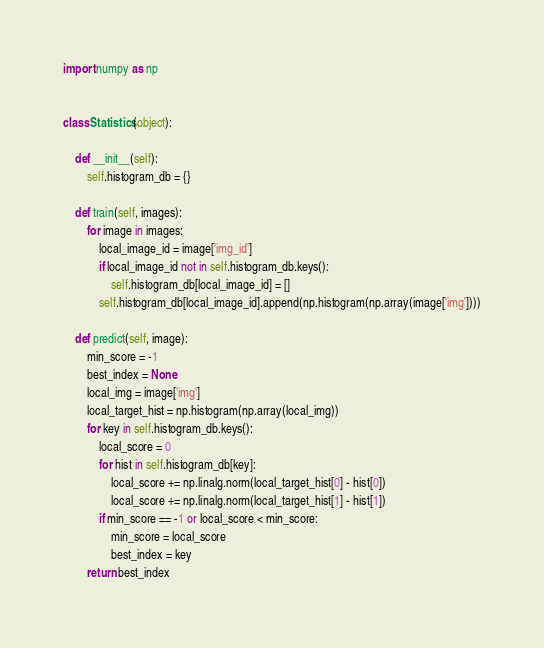<code> <loc_0><loc_0><loc_500><loc_500><_Python_>import numpy as np


class Statistics(object):

    def __init__(self):
        self.histogram_db = {}

    def train(self, images):
        for image in images:
            local_image_id = image['img_id']
            if local_image_id not in self.histogram_db.keys():
                self.histogram_db[local_image_id] = []
            self.histogram_db[local_image_id].append(np.histogram(np.array(image['img'])))

    def predict(self, image):
        min_score = -1
        best_index = None
        local_img = image['img']
        local_target_hist = np.histogram(np.array(local_img))
        for key in self.histogram_db.keys():
            local_score = 0
            for hist in self.histogram_db[key]:
                local_score += np.linalg.norm(local_target_hist[0] - hist[0])
                local_score += np.linalg.norm(local_target_hist[1] - hist[1])
            if min_score == -1 or local_score < min_score:
                min_score = local_score
                best_index = key
        return best_index
</code> 